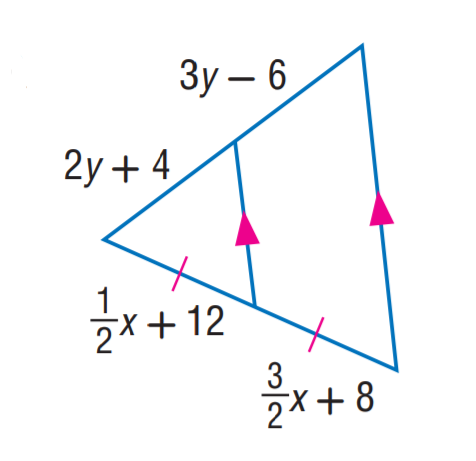Question: Find y.
Choices:
A. 8
B. 10
C. 12
D. 14
Answer with the letter. Answer: B Question: Find x.
Choices:
A. 4
B. 6
C. 8
D. 10
Answer with the letter. Answer: A 